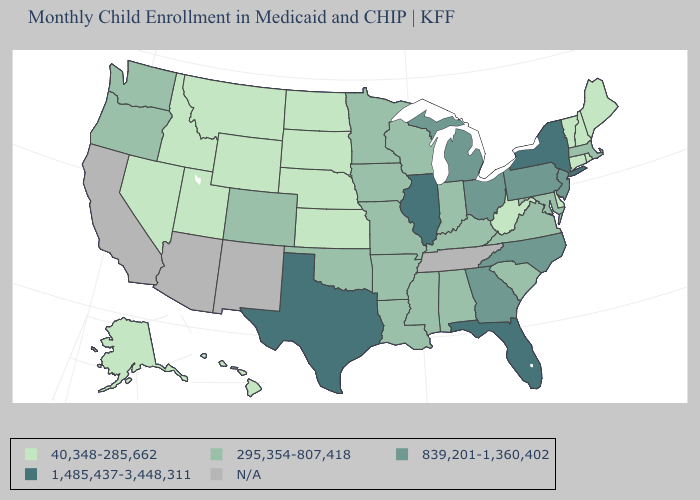Name the states that have a value in the range 40,348-285,662?
Be succinct. Alaska, Connecticut, Delaware, Hawaii, Idaho, Kansas, Maine, Montana, Nebraska, Nevada, New Hampshire, North Dakota, Rhode Island, South Dakota, Utah, Vermont, West Virginia, Wyoming. Does Florida have the lowest value in the USA?
Quick response, please. No. How many symbols are there in the legend?
Keep it brief. 5. What is the lowest value in the USA?
Write a very short answer. 40,348-285,662. Name the states that have a value in the range 295,354-807,418?
Short answer required. Alabama, Arkansas, Colorado, Indiana, Iowa, Kentucky, Louisiana, Maryland, Massachusetts, Minnesota, Mississippi, Missouri, Oklahoma, Oregon, South Carolina, Virginia, Washington, Wisconsin. Which states have the lowest value in the Northeast?
Short answer required. Connecticut, Maine, New Hampshire, Rhode Island, Vermont. What is the lowest value in the USA?
Quick response, please. 40,348-285,662. Among the states that border Indiana , does Ohio have the highest value?
Short answer required. No. Does the first symbol in the legend represent the smallest category?
Concise answer only. Yes. What is the value of Tennessee?
Be succinct. N/A. What is the value of New Jersey?
Answer briefly. 839,201-1,360,402. What is the lowest value in states that border New Hampshire?
Quick response, please. 40,348-285,662. What is the lowest value in states that border Nevada?
Concise answer only. 40,348-285,662. 